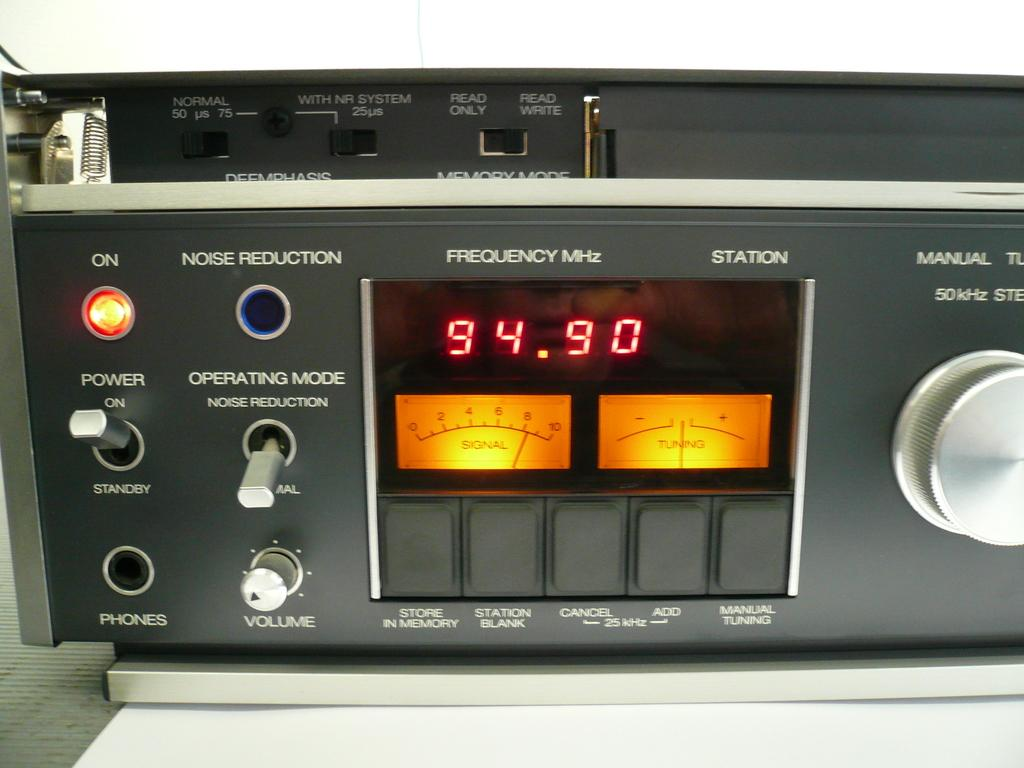<image>
Offer a succinct explanation of the picture presented. A stereo component with flips and dials and a jack for phones. 